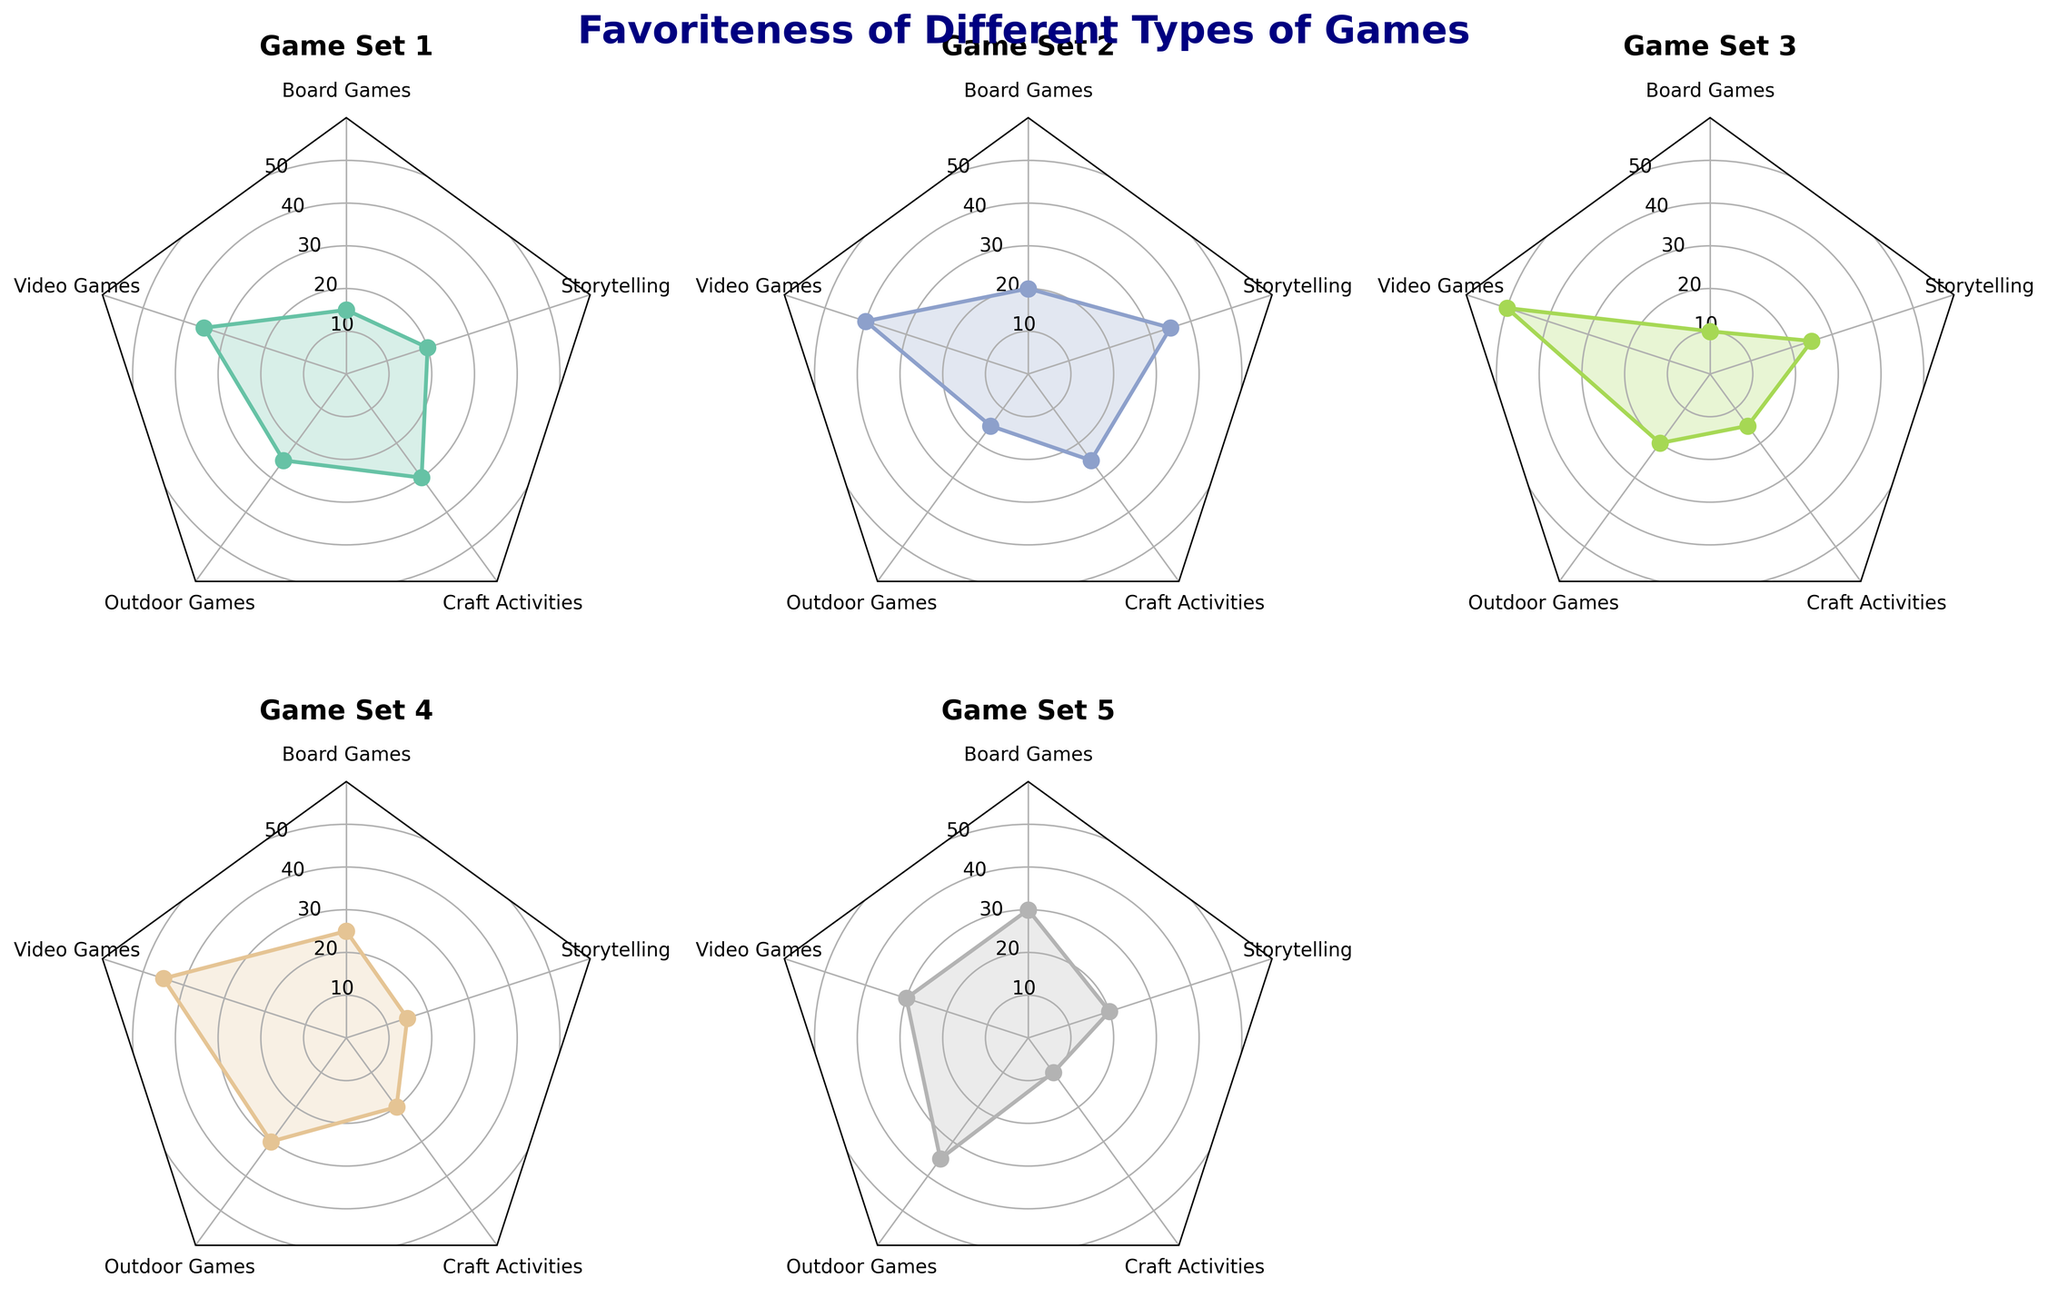Which game type is most favored in Game Set 3? In Game Set 3, we need to check the highest value among the five game types (Board Games, Video Games, Outdoor Games, Craft Activities, Storytelling). From the data, Video Games have the highest favoriteness at 50.
Answer: Video Games Which game type is least favored in Game Set 4? In Game Set 4, we need to identify the smallest value among the five game types. Storytelling has the lowest favoriteness at 15.
Answer: Storytelling What is the range of favoriteness for Outdoor Games across all game sets? We calculate the range by finding the difference between the maximum and minimum values of Outdoor Games, which are 35 and 15 respectively. The range is 35 - 15 = 20.
Answer: 20 Which game set has the highest average favoriteness across all game types? To find the average, sum up the values of all game types for each game set, then divide by 5. The averages for Game Sets 1-5 are: (15+35+25+30+20)/5=25, (20+40+15+25+35)/5=27, (10+50+20+15+25)/5=24, (25+45+30+20+15)/5=27, (30+30+35+10+20)/5=25. Hence, Game Sets 2 and 4 have the highest average favoriteness of 27.
Answer: Game Set 2 and Game Set 4 In which game set is the difference between the highest and lowest favoriteness values the greatest? Calculate the difference between the highest and lowest values for each game set. The differences are: Game Set 1: 35-15=20, Game Set 2: 40-15=25, Game Set 3: 50-10=40, Game Set 4: 45-15=30, Game Set 5: 35-10=25. The greatest difference is in Game Set 3, which is 40.
Answer: Game Set 3 Which game type has the most consistent favoriteness across all game sets? A game type with consistent favoriteness will have the smallest range between its maximum and minimum values. Analyzing all game sets: Board Games (range is 30-10=20), Video Games (50-30=20), Outdoor Games (35-15=20), Craft Activities (30-10=20), Storytelling (35-15=20). All game types have the same range of 20, indicating similar consistency.
Answer: All game types What is the median favoriteness value of Storytelling across all game sets? To find the median, first list the Storytelling values in ascending order: 15, 15, 20, 20, 35. The middle value from this ordered list is the median, which is 20.
Answer: 20 